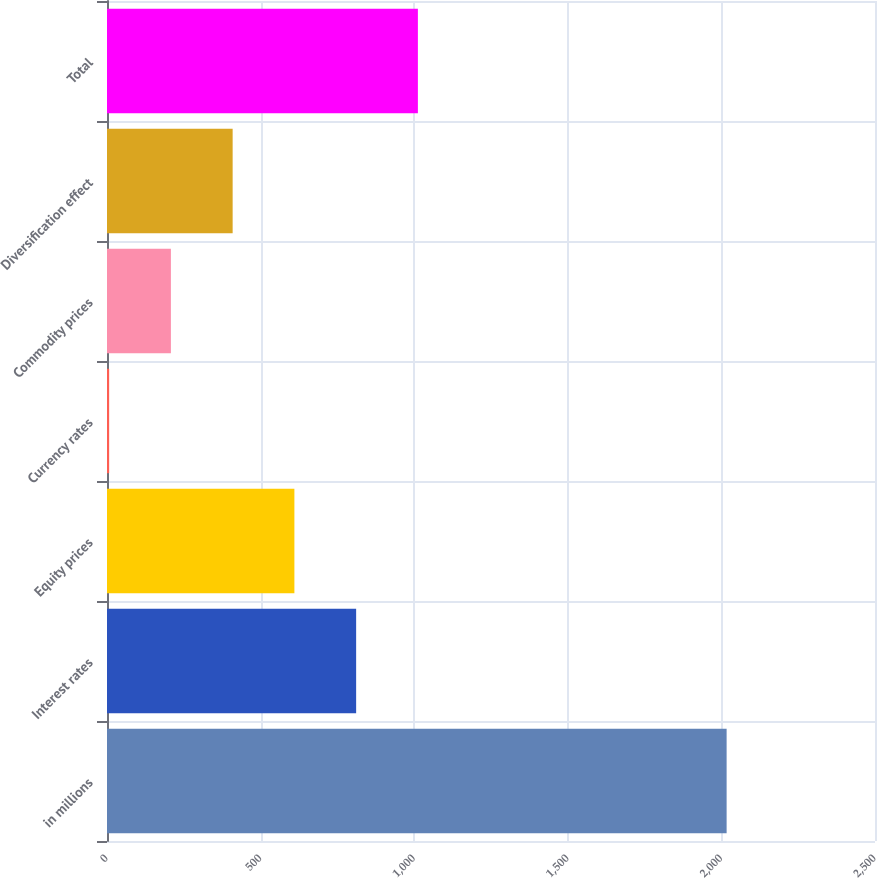Convert chart. <chart><loc_0><loc_0><loc_500><loc_500><bar_chart><fcel>in millions<fcel>Interest rates<fcel>Equity prices<fcel>Currency rates<fcel>Commodity prices<fcel>Diversification effect<fcel>Total<nl><fcel>2017<fcel>811<fcel>610<fcel>7<fcel>208<fcel>409<fcel>1012<nl></chart> 